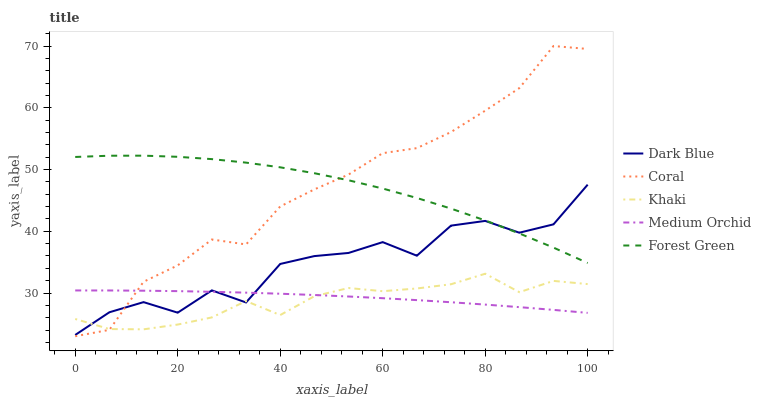Does Coral have the minimum area under the curve?
Answer yes or no. No. Does Khaki have the maximum area under the curve?
Answer yes or no. No. Is Coral the smoothest?
Answer yes or no. No. Is Coral the roughest?
Answer yes or no. No. Does Khaki have the lowest value?
Answer yes or no. No. Does Khaki have the highest value?
Answer yes or no. No. Is Khaki less than Forest Green?
Answer yes or no. Yes. Is Forest Green greater than Khaki?
Answer yes or no. Yes. Does Khaki intersect Forest Green?
Answer yes or no. No. 